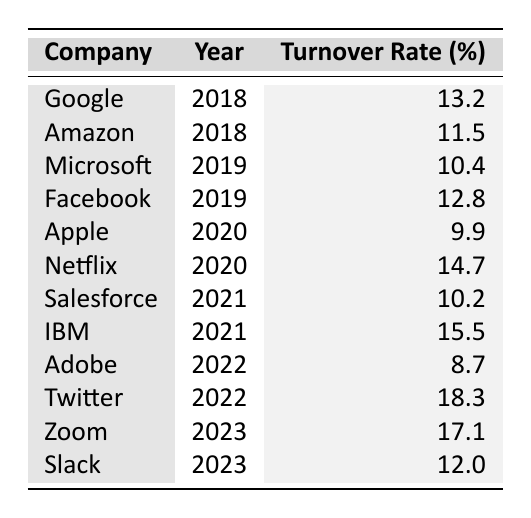What was the turnover rate for Google in 2018? The table lists Google under the year 2018 with a turnover rate of 13.2%.
Answer: 13.2% Which company had the highest turnover rate in 2022? From the table, Twitter is listed in 2022 with a turnover rate of 18.3%, the highest among all entries for that year.
Answer: Twitter What is the average turnover rate for technology companies in 2020? The companies listed for 2020 are Apple (9.9%) and Netflix (14.7%). The average is calculated as (9.9 + 14.7) / 2 = 12.3%.
Answer: 12.3% Was the turnover rate for IBM in 2021 higher than 15%? IBM's turnover rate for 2021 is 15.5%, which is indeed higher than 15%.
Answer: Yes Which company experienced the largest decrease in turnover rate from 2019 to 2020? In 2019, Facebook had a turnover rate of 12.8%, and in 2020, Apple had a turnover rate of 9.9%. The decrease is 12.8 - 9.9 = 2.9%. This shows that Facebook had the largest decrease since Apple's rate is for a different year.
Answer: Facebook What was the trend in turnover rates from 2018 to 2023? By analyzing the data: 2018 (average of 12.4%), 2019 (average of 11.6%), 2020 (average of 12.3%), 2021 (average of 12.9%), 2022 (average of 13.5%), 2023 (average of 14.6%). The data indicates a general upward trend from 2018 to 2023.
Answer: Upward trend Did any company have a turnover rate of 10% or less in 2021? The table shows that Salesforce had a turnover rate of 10.2% in 2021, which is greater than 10%. So, no company had a turnover rate of 10% or less.
Answer: No What was the increase in turnover rate from Adobe in 2022 to Zoom in 2023? Adobe's turnover rate in 2022 was 8.7%, and Zoom's turnover rate in 2023 was 17.1%. The increase is 17.1 - 8.7 = 8.4%.
Answer: 8.4% 